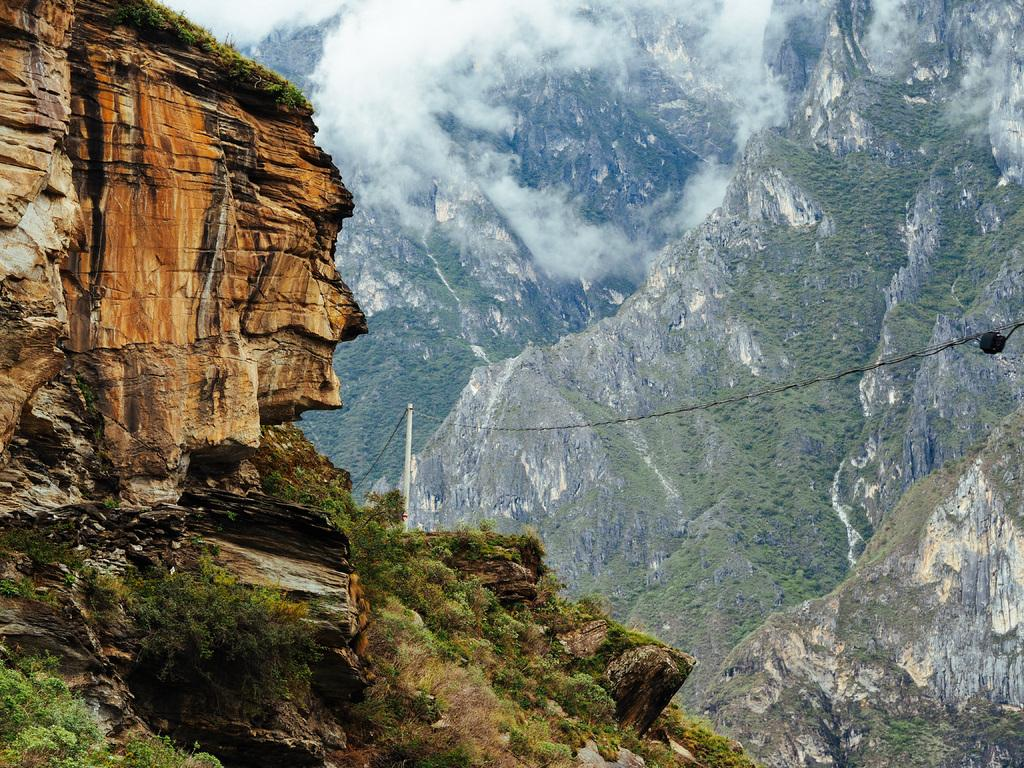What type of vegetation can be seen in the image? There are trees in the image. What man-made structure is present in the image? There is an electric pole in the image. What natural feature can be seen in the distance in the image? There are mountains visible in the background of the image. What type of flowers can be seen growing on the electric pole in the image? There are no flowers growing on the electric pole in the image. Who is the porter in the image? There is no porter present in the image. 